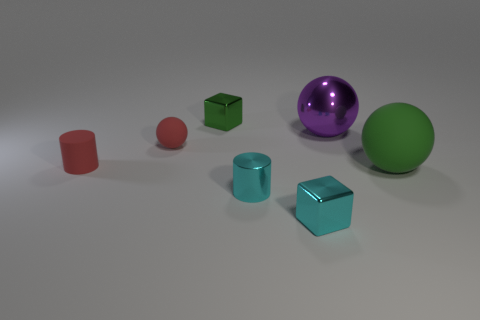Are there any rubber spheres of the same color as the small rubber cylinder?
Provide a short and direct response. Yes. How many objects are either large green spheres or tiny red things?
Give a very brief answer. 3. There is a purple object that is the same material as the tiny green block; what shape is it?
Provide a succinct answer. Sphere. There is a thing that is left of the red ball that is in front of the purple metal object; what is its size?
Your answer should be compact. Small. How many tiny things are purple metal balls or brown shiny objects?
Provide a succinct answer. 0. What number of other objects are there of the same color as the big metal ball?
Your answer should be very brief. 0. There is a rubber sphere that is to the right of the small rubber ball; does it have the same size as the red matte ball that is on the left side of the green metal object?
Make the answer very short. No. Are the tiny cyan cube and the big ball that is left of the big green sphere made of the same material?
Provide a succinct answer. Yes. Is the number of red things that are on the right side of the large purple sphere greater than the number of large balls that are behind the green shiny block?
Your answer should be compact. No. What is the color of the small block behind the rubber object right of the red rubber ball?
Give a very brief answer. Green. 